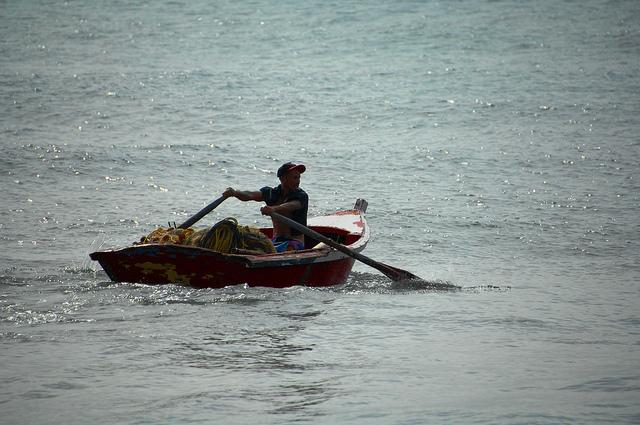How does the boat move?
Short answer required. Rowing. Is he fishing?
Keep it brief. No. How many people are in the boat?
Concise answer only. 1. How many oars can be seen?
Be succinct. 2. 